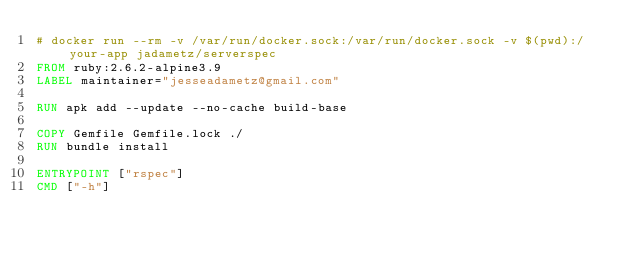Convert code to text. <code><loc_0><loc_0><loc_500><loc_500><_Dockerfile_># docker run --rm -v /var/run/docker.sock:/var/run/docker.sock -v $(pwd):/your-app jadametz/serverspec
FROM ruby:2.6.2-alpine3.9
LABEL maintainer="jesseadametz@gmail.com"

RUN apk add --update --no-cache build-base

COPY Gemfile Gemfile.lock ./
RUN bundle install

ENTRYPOINT ["rspec"]
CMD ["-h"]
</code> 